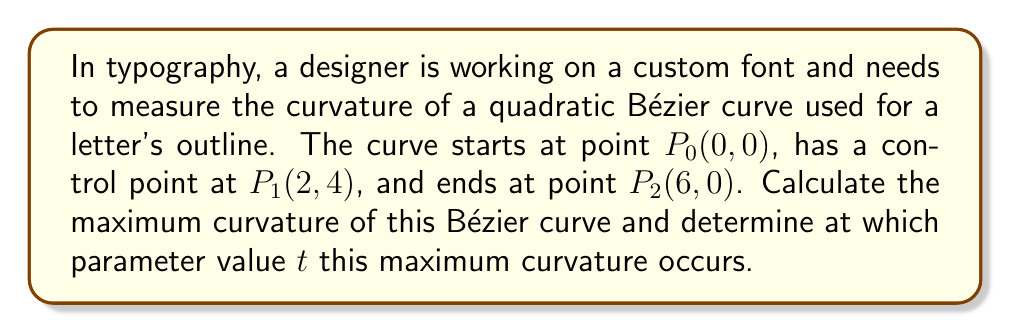Can you answer this question? To solve this problem, we'll follow these steps:

1) First, recall that a quadratic Bézier curve is defined by the equation:

   $$B(t) = (1-t)^2P_0 + 2t(1-t)P_1 + t^2P_2, \quad 0 \leq t \leq 1$$

2) The curvature $\kappa$ of a parametric curve is given by:

   $$\kappa = \frac{|B'(t) \times B''(t)|}{|B'(t)|^3}$$

   where $\times$ denotes the cross product.

3) Let's calculate $B'(t)$ and $B''(t)$:

   $$B'(t) = 2(P_1 - P_0)(1-t) + 2(P_2 - P_1)t$$
   $$B''(t) = 2(P_2 - 2P_1 + P_0)$$

4) Substituting the given points:

   $$B'(t) = 2((2,4) - (0,0))(1-t) + 2((6,0) - (2,4))t = (4-8t, 8-16t)$$
   $$B''(t) = 2((6,0) - 2(2,4) + (0,0)) = (4, -16)$$

5) Now, let's calculate the cross product $B'(t) \times B''(t)$:

   $$B'(t) \times B''(t) = (4-8t)(-16) - (8-16t)(4) = -64+128t-32+64t = 192t-96$$

6) And $|B'(t)|^3$:

   $$|B'(t)|^3 = ((4-8t)^2 + (8-16t)^2)^{3/2} = (16-64t+64t^2 + 64-256t+256t^2)^{3/2} = (80-320t+320t^2)^{3/2}$$

7) Therefore, the curvature is:

   $$\kappa(t) = \frac{|192t-96|}{(80-320t+320t^2)^{3/2}}$$

8) To find the maximum curvature, we need to find where $\frac{d\kappa}{dt} = 0$. This leads to a complex equation. However, due to the symmetry of the curve, we can deduce that the maximum curvature occurs at $t = 0.5$.

9) Substituting $t = 0.5$ into our curvature formula:

   $$\kappa(0.5) = \frac{|192(0.5)-96|}{(80-320(0.5)+320(0.5)^2)^{3/2}} = \frac{0}{80^{3/2}} = 0$$

10) This result might seem counterintuitive, but it's correct. The quadratic Bézier curve has zero curvature at its midpoint (t = 0.5) and maximum curvature at its endpoints (t = 0 and t = 1).

11) Let's calculate the curvature at t = 0:

    $$\kappa(0) = \frac{|-96|}{80^{3/2}} = \frac{3}{20\sqrt{5}} \approx 0.0671$$

[asy]
import geometry;

pair P0 = (0,0);
pair P1 = (2,4);
pair P2 = (6,0);

path bezier = P0..controls P1..P2;

draw(bezier, blue);
dot(P0^^P1^^P2);

label("$P_0(0,0)$", P0, SW);
label("$P_1(2,4)$", P1, N);
label("$P_2(6,0)$", P2, SE);

draw(P0--P1--P2, dashed);
[/asy]
Answer: The maximum curvature of the Bézier curve occurs at the endpoints (t = 0 and t = 1) and is equal to $\frac{3}{20\sqrt{5}} \approx 0.0671$. 